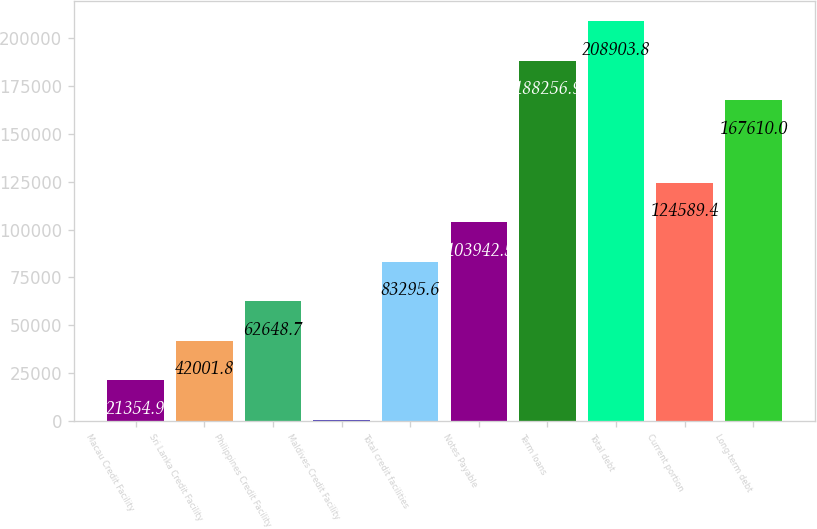Convert chart. <chart><loc_0><loc_0><loc_500><loc_500><bar_chart><fcel>Macau Credit Facility<fcel>Sri Lanka Credit Facility<fcel>Philippines Credit Facility<fcel>Maldives Credit Facility<fcel>Total credit facilities<fcel>Notes Payable<fcel>Term loans<fcel>Total debt<fcel>Current portion<fcel>Long-term debt<nl><fcel>21354.9<fcel>42001.8<fcel>62648.7<fcel>708<fcel>83295.6<fcel>103942<fcel>188257<fcel>208904<fcel>124589<fcel>167610<nl></chart> 